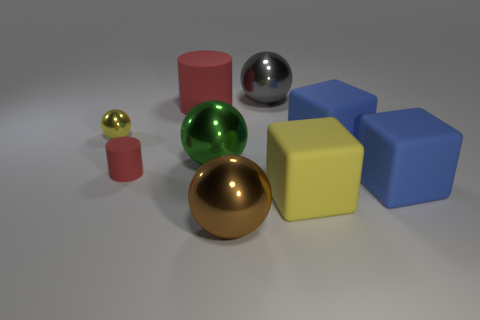Add 1 gray balls. How many objects exist? 10 Subtract all gray balls. How many balls are left? 3 Subtract all large yellow matte cubes. Subtract all blue objects. How many objects are left? 6 Add 4 gray spheres. How many gray spheres are left? 5 Add 9 big green matte balls. How many big green matte balls exist? 9 Subtract all yellow blocks. How many blocks are left? 2 Subtract 0 red balls. How many objects are left? 9 Subtract all balls. How many objects are left? 5 Subtract 1 cylinders. How many cylinders are left? 1 Subtract all brown cubes. Subtract all red cylinders. How many cubes are left? 3 